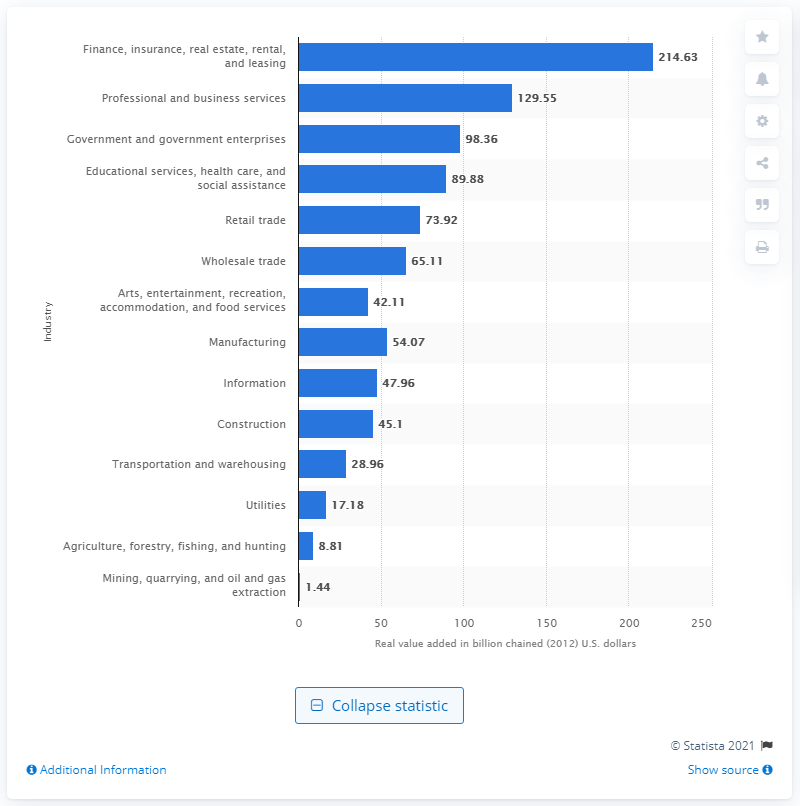List a handful of essential elements in this visual. In 2012, the mining industry contributed 1.44 billion dollars to the Gross Domestic Product (GDP) of Florida. 